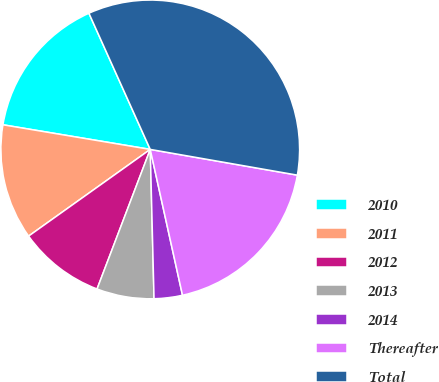Convert chart. <chart><loc_0><loc_0><loc_500><loc_500><pie_chart><fcel>2010<fcel>2011<fcel>2012<fcel>2013<fcel>2014<fcel>Thereafter<fcel>Total<nl><fcel>15.63%<fcel>12.49%<fcel>9.35%<fcel>6.2%<fcel>3.06%<fcel>18.78%<fcel>34.49%<nl></chart> 